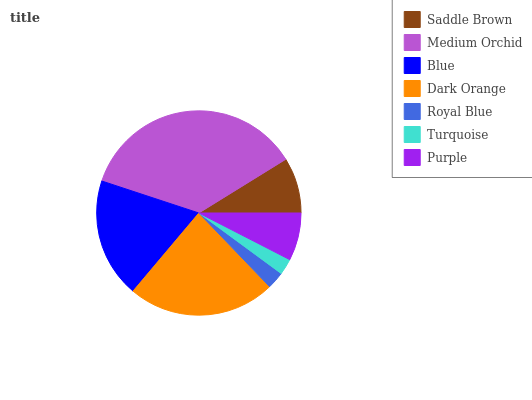Is Turquoise the minimum?
Answer yes or no. Yes. Is Medium Orchid the maximum?
Answer yes or no. Yes. Is Blue the minimum?
Answer yes or no. No. Is Blue the maximum?
Answer yes or no. No. Is Medium Orchid greater than Blue?
Answer yes or no. Yes. Is Blue less than Medium Orchid?
Answer yes or no. Yes. Is Blue greater than Medium Orchid?
Answer yes or no. No. Is Medium Orchid less than Blue?
Answer yes or no. No. Is Saddle Brown the high median?
Answer yes or no. Yes. Is Saddle Brown the low median?
Answer yes or no. Yes. Is Blue the high median?
Answer yes or no. No. Is Blue the low median?
Answer yes or no. No. 